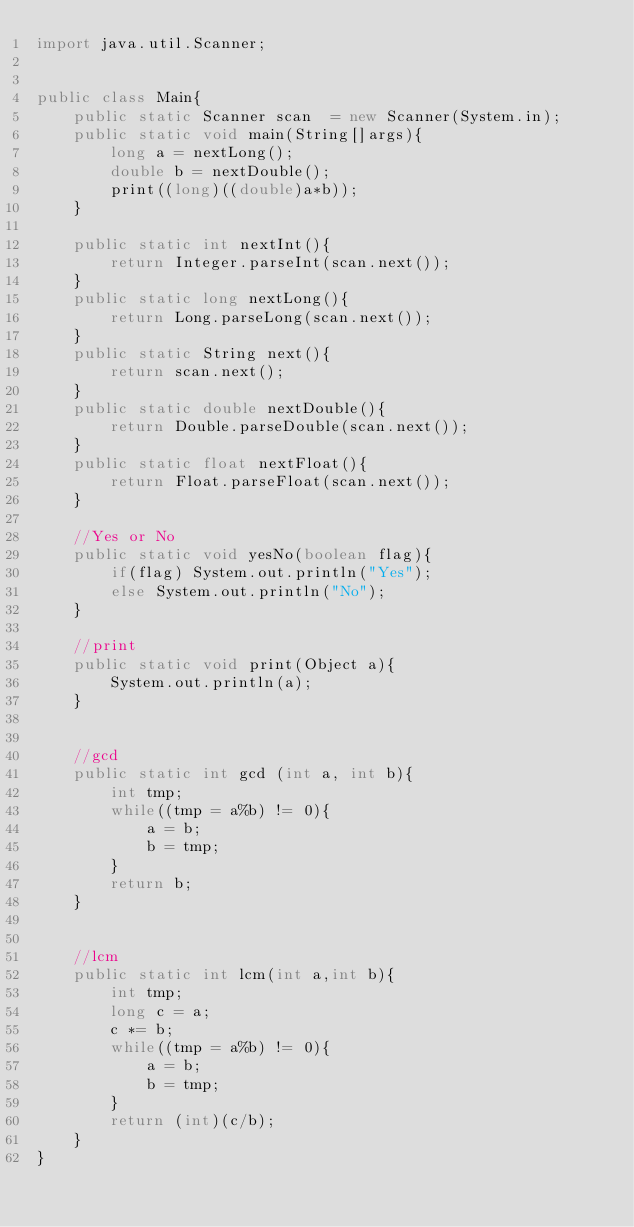<code> <loc_0><loc_0><loc_500><loc_500><_Java_>import java.util.Scanner;


public class Main{
    public static Scanner scan  = new Scanner(System.in);
    public static void main(String[]args){
        long a = nextLong();
        double b = nextDouble();
        print((long)((double)a*b));
    }

    public static int nextInt(){
        return Integer.parseInt(scan.next());
    }
    public static long nextLong(){
        return Long.parseLong(scan.next());
    }
    public static String next(){
        return scan.next();
    }
    public static double nextDouble(){
        return Double.parseDouble(scan.next());
    }
    public static float nextFloat(){
        return Float.parseFloat(scan.next());
    }

    //Yes or No
    public static void yesNo(boolean flag){
        if(flag) System.out.println("Yes");
        else System.out.println("No");
    }

    //print
    public static void print(Object a){
        System.out.println(a);
    }


    //gcd
    public static int gcd (int a, int b){
        int tmp;
        while((tmp = a%b) != 0){
            a = b;
            b = tmp;
        }
        return b;
    }


    //lcm
    public static int lcm(int a,int b){
        int tmp;
        long c = a;
        c *= b;
        while((tmp = a%b) != 0){
            a = b;
            b = tmp;
        }
        return (int)(c/b);
    }
}</code> 